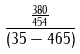Convert formula to latex. <formula><loc_0><loc_0><loc_500><loc_500>\frac { \frac { 3 8 0 } { 4 5 4 } } { ( 3 5 - 4 6 5 ) }</formula> 